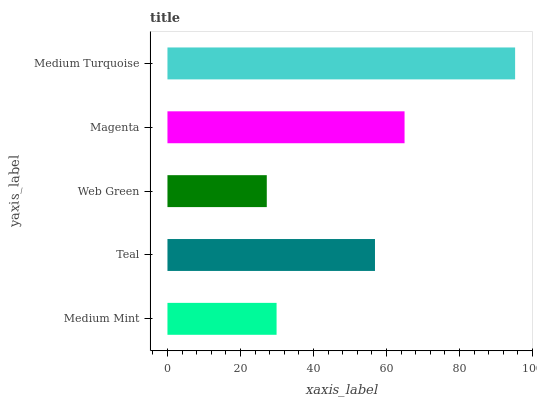Is Web Green the minimum?
Answer yes or no. Yes. Is Medium Turquoise the maximum?
Answer yes or no. Yes. Is Teal the minimum?
Answer yes or no. No. Is Teal the maximum?
Answer yes or no. No. Is Teal greater than Medium Mint?
Answer yes or no. Yes. Is Medium Mint less than Teal?
Answer yes or no. Yes. Is Medium Mint greater than Teal?
Answer yes or no. No. Is Teal less than Medium Mint?
Answer yes or no. No. Is Teal the high median?
Answer yes or no. Yes. Is Teal the low median?
Answer yes or no. Yes. Is Web Green the high median?
Answer yes or no. No. Is Web Green the low median?
Answer yes or no. No. 